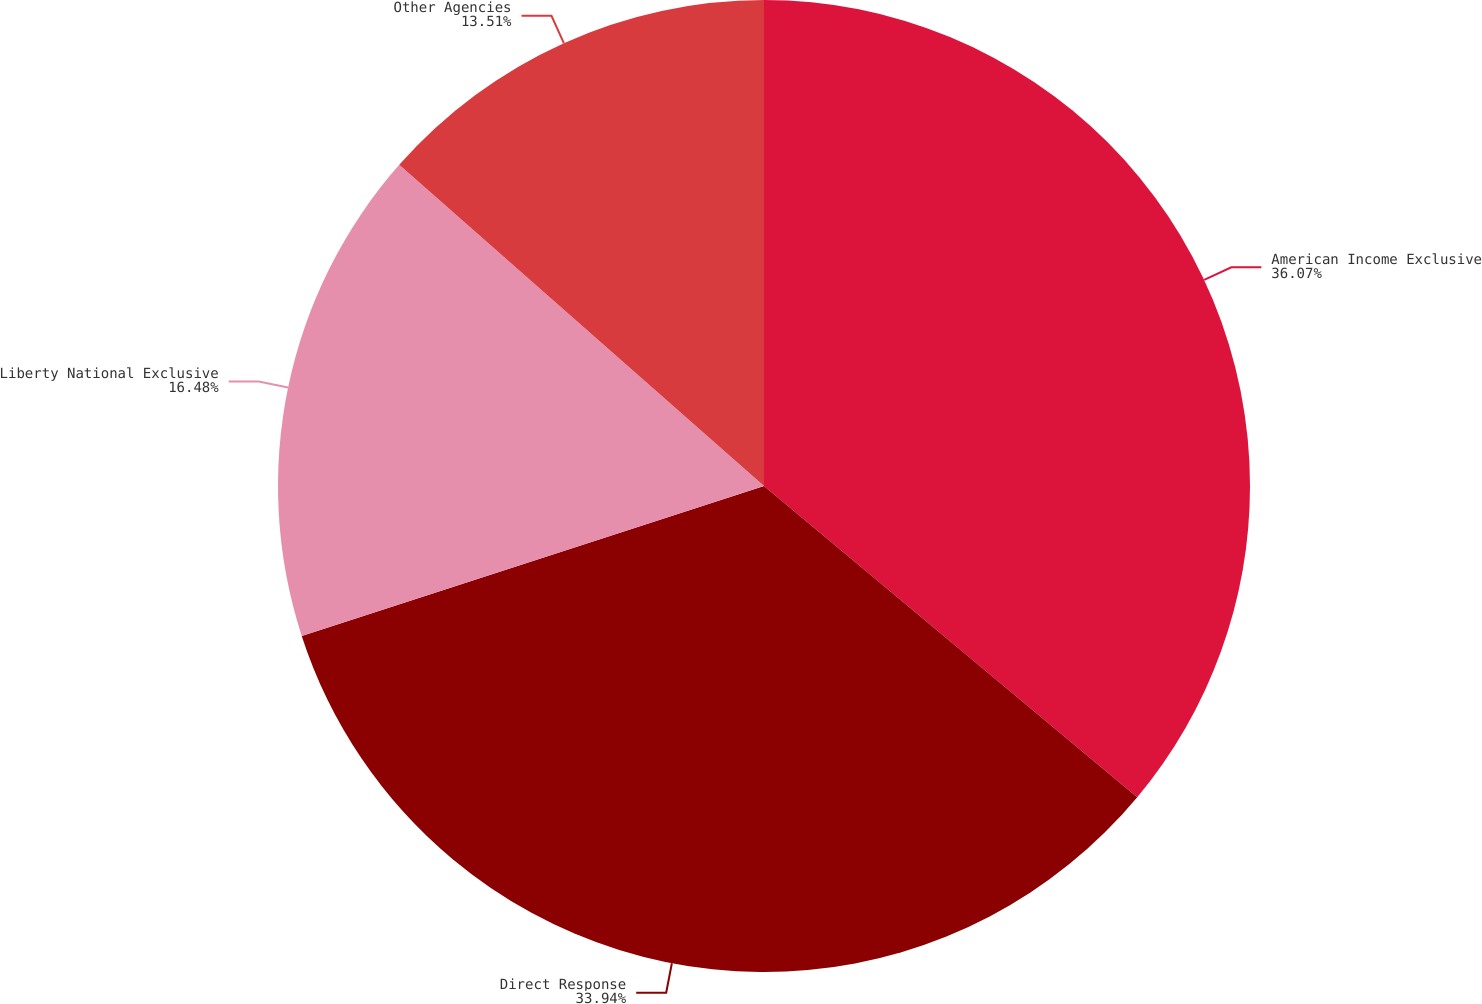Convert chart. <chart><loc_0><loc_0><loc_500><loc_500><pie_chart><fcel>American Income Exclusive<fcel>Direct Response<fcel>Liberty National Exclusive<fcel>Other Agencies<nl><fcel>36.06%<fcel>33.94%<fcel>16.48%<fcel>13.51%<nl></chart> 